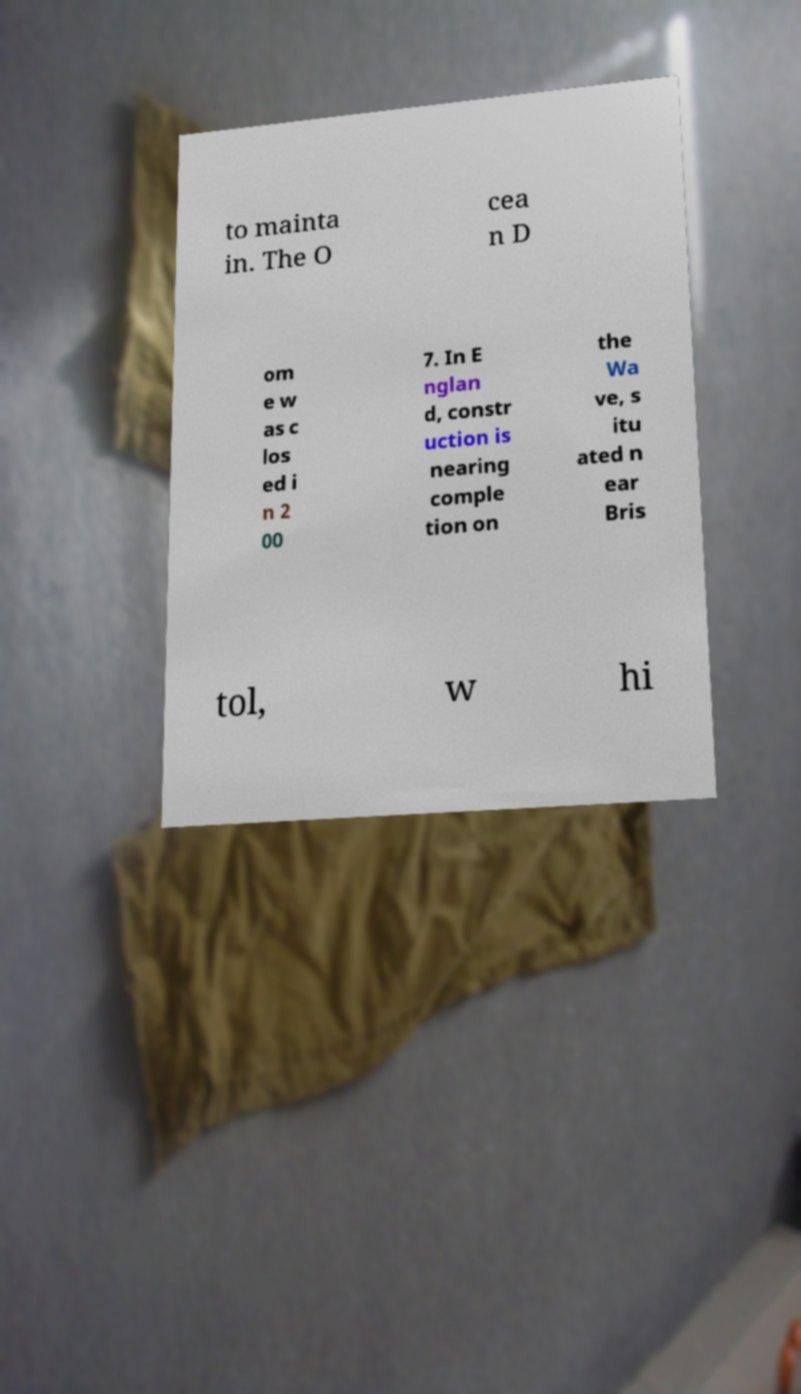Can you accurately transcribe the text from the provided image for me? to mainta in. The O cea n D om e w as c los ed i n 2 00 7. In E nglan d, constr uction is nearing comple tion on the Wa ve, s itu ated n ear Bris tol, w hi 